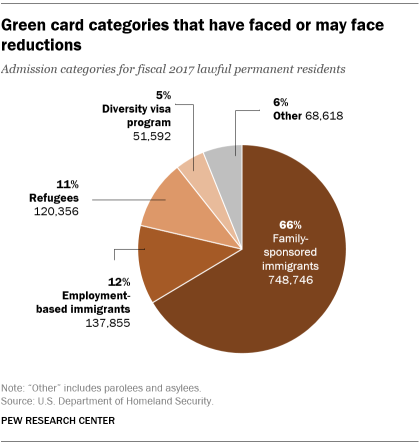List a handful of essential elements in this visual. The biggest face has a percentage value of 66%. The percentage of the biggest face and the smallest face in the image is 61%. 